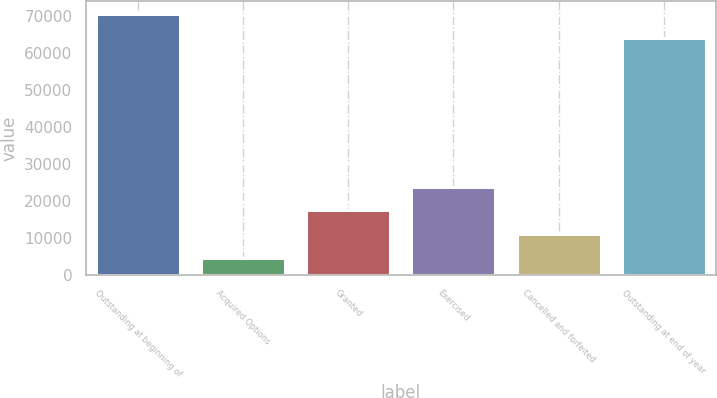<chart> <loc_0><loc_0><loc_500><loc_500><bar_chart><fcel>Outstanding at beginning of<fcel>Acquired Options<fcel>Granted<fcel>Exercised<fcel>Cancelled and forfeited<fcel>Outstanding at end of year<nl><fcel>70382.6<fcel>4557<fcel>17430.2<fcel>23866.8<fcel>10993.6<fcel>63946<nl></chart> 